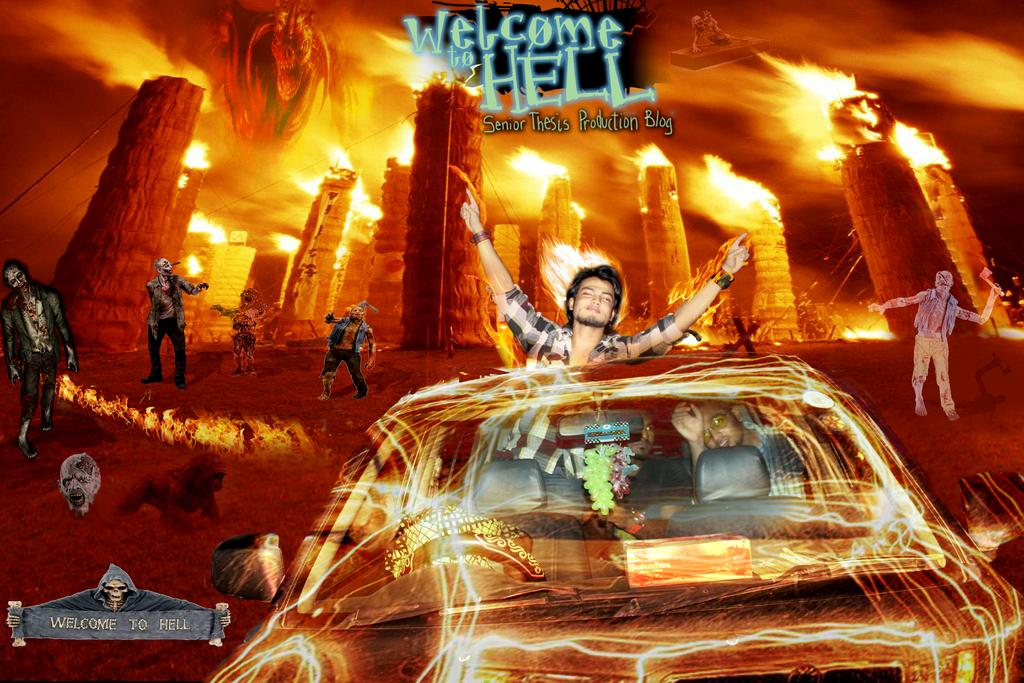<image>
Write a terse but informative summary of the picture. An image of a man standing partially outside of a car in front of images of burning buildings and zombies says welcome to hell. 